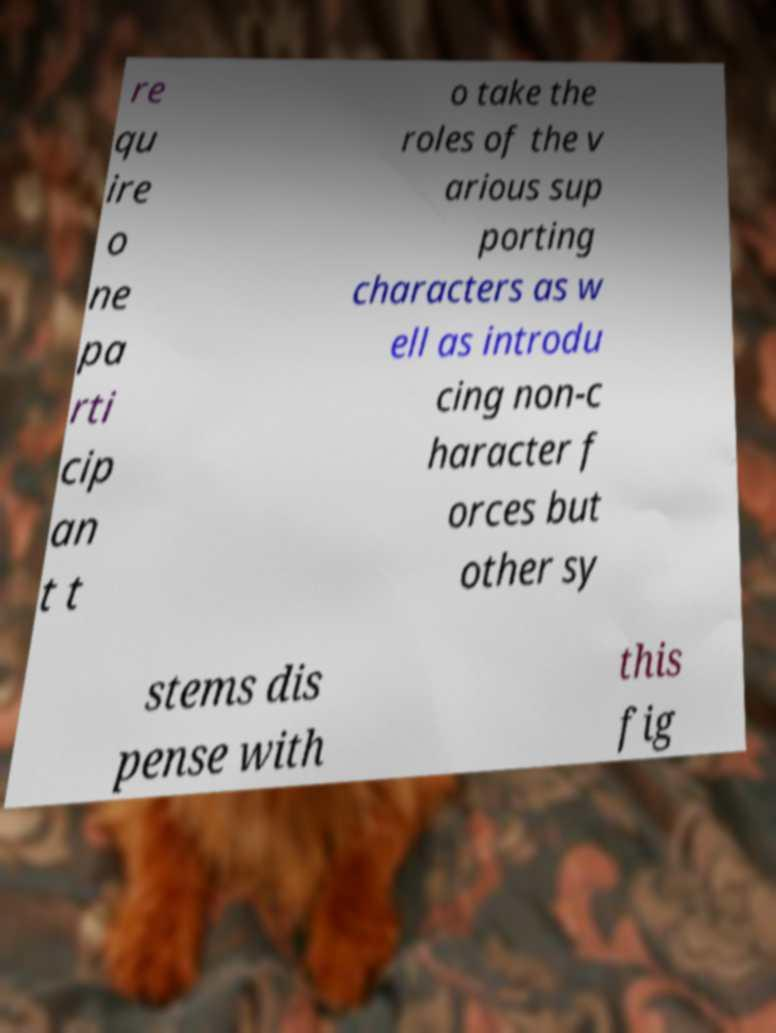There's text embedded in this image that I need extracted. Can you transcribe it verbatim? re qu ire o ne pa rti cip an t t o take the roles of the v arious sup porting characters as w ell as introdu cing non-c haracter f orces but other sy stems dis pense with this fig 